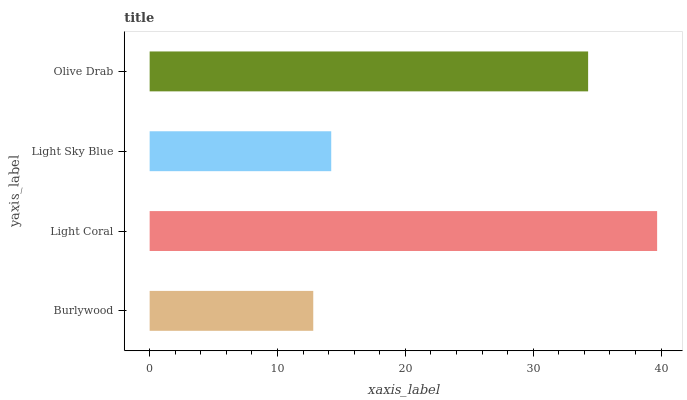Is Burlywood the minimum?
Answer yes or no. Yes. Is Light Coral the maximum?
Answer yes or no. Yes. Is Light Sky Blue the minimum?
Answer yes or no. No. Is Light Sky Blue the maximum?
Answer yes or no. No. Is Light Coral greater than Light Sky Blue?
Answer yes or no. Yes. Is Light Sky Blue less than Light Coral?
Answer yes or no. Yes. Is Light Sky Blue greater than Light Coral?
Answer yes or no. No. Is Light Coral less than Light Sky Blue?
Answer yes or no. No. Is Olive Drab the high median?
Answer yes or no. Yes. Is Light Sky Blue the low median?
Answer yes or no. Yes. Is Burlywood the high median?
Answer yes or no. No. Is Olive Drab the low median?
Answer yes or no. No. 